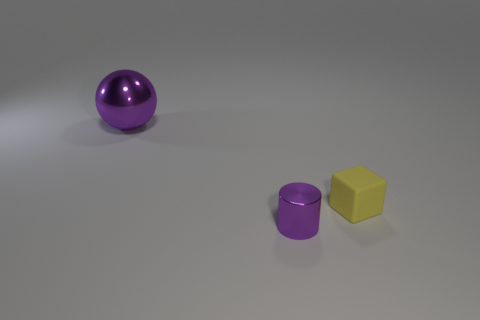There is a tiny metal thing; is it the same shape as the thing that is on the left side of the tiny purple cylinder?
Give a very brief answer. No. There is a purple shiny thing that is behind the metallic thing on the right side of the purple shiny object behind the purple cylinder; what shape is it?
Provide a succinct answer. Sphere. What number of other objects are there of the same material as the tiny cube?
Give a very brief answer. 0. What number of things are either purple metal things that are behind the yellow thing or matte blocks?
Provide a succinct answer. 2. What is the shape of the purple object behind the shiny object in front of the big purple ball?
Provide a short and direct response. Sphere. Is the shape of the purple shiny object that is in front of the big purple object the same as  the yellow rubber thing?
Make the answer very short. No. What is the color of the metal thing that is behind the yellow block?
Provide a short and direct response. Purple. What number of blocks are either large purple objects or yellow things?
Offer a terse response. 1. What is the size of the purple metal object that is behind the purple metal object in front of the large purple ball?
Provide a short and direct response. Large. There is a big thing; does it have the same color as the small thing behind the purple shiny cylinder?
Ensure brevity in your answer.  No. 